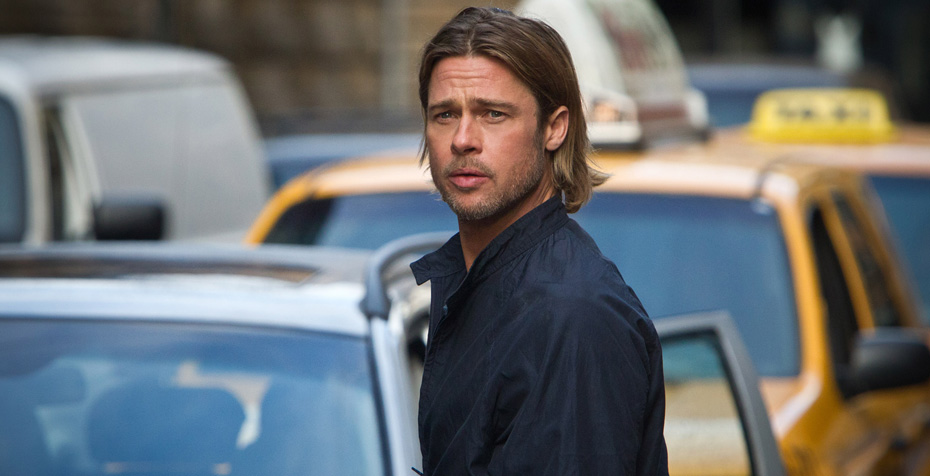Write a detailed description of the given image. In the image, a man who appears to be a well-known actor is captured walking on a city street. He is dressed in a navy blue jacket, and his shoulder-length blonde hair flows loosely around his face. His facial expression is serious, possibly indicating deep thought or concentration. As he strides forward with focused determination, he passes by a line of parked cars, including a distinctive yellow taxi cab in the background. The urban setting is evident from the surrounding buildings, enhancing the image's cityscape atmosphere. 